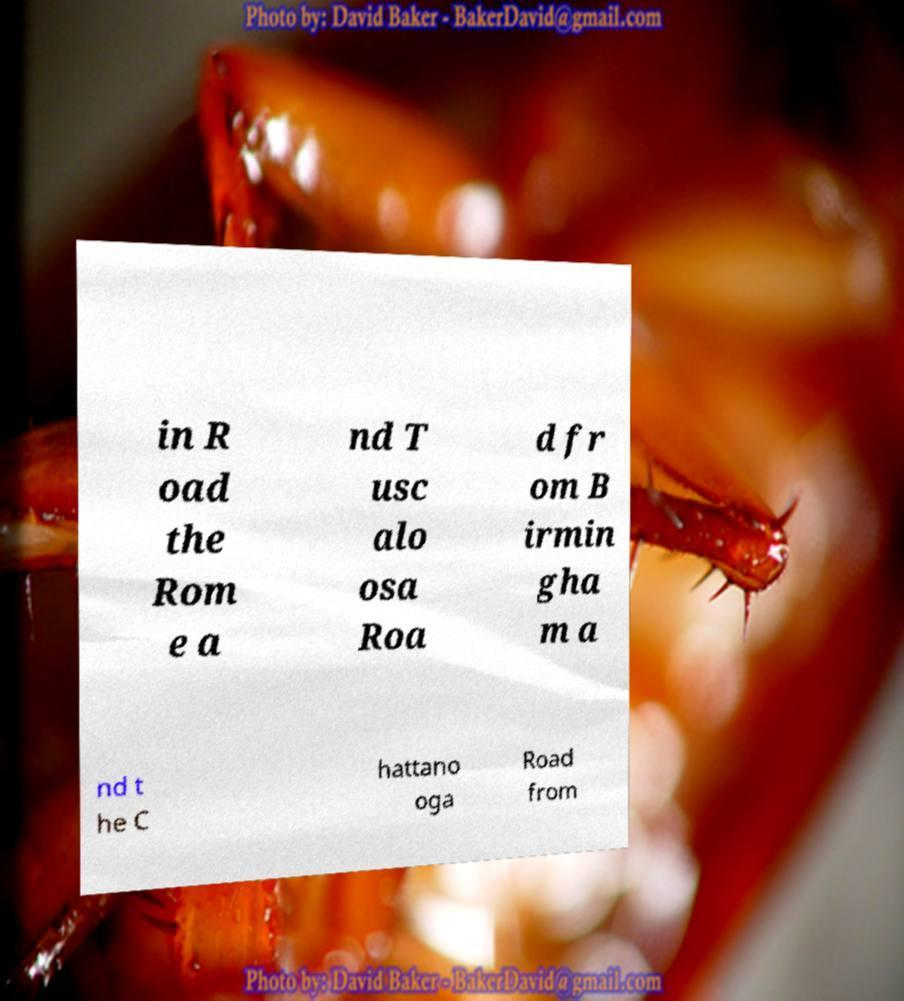What messages or text are displayed in this image? I need them in a readable, typed format. in R oad the Rom e a nd T usc alo osa Roa d fr om B irmin gha m a nd t he C hattano oga Road from 